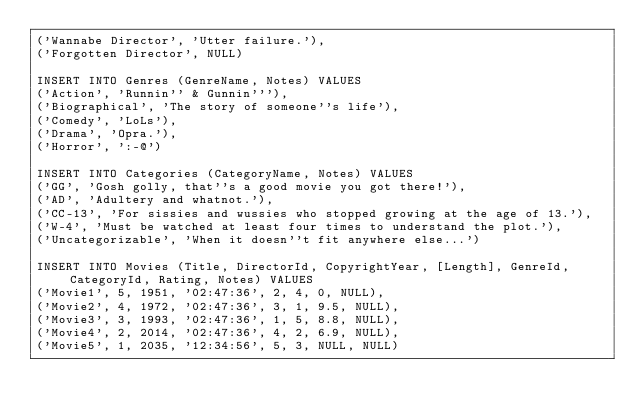Convert code to text. <code><loc_0><loc_0><loc_500><loc_500><_SQL_>('Wannabe Director', 'Utter failure.'),
('Forgotten Director', NULL)

INSERT INTO Genres (GenreName, Notes) VALUES
('Action', 'Runnin'' & Gunnin'''),
('Biographical', 'The story of someone''s life'),
('Comedy', 'LoLs'),
('Drama', 'Opra.'),
('Horror', ':-@')

INSERT INTO Categories (CategoryName, Notes) VALUES
('GG', 'Gosh golly, that''s a good movie you got there!'),
('AD', 'Adultery and whatnot.'),
('CC-13', 'For sissies and wussies who stopped growing at the age of 13.'),
('W-4', 'Must be watched at least four times to understand the plot.'),
('Uncategorizable', 'When it doesn''t fit anywhere else...')

INSERT INTO Movies (Title, DirectorId, CopyrightYear, [Length], GenreId, CategoryId, Rating, Notes) VALUES
('Movie1', 5, 1951, '02:47:36', 2, 4, 0, NULL),
('Movie2', 4, 1972, '02:47:36', 3, 1, 9.5, NULL),
('Movie3', 3, 1993, '02:47:36', 1, 5, 8.8, NULL),
('Movie4', 2, 2014, '02:47:36', 4, 2, 6.9, NULL),
('Movie5', 1, 2035, '12:34:56', 5, 3, NULL, NULL)
</code> 